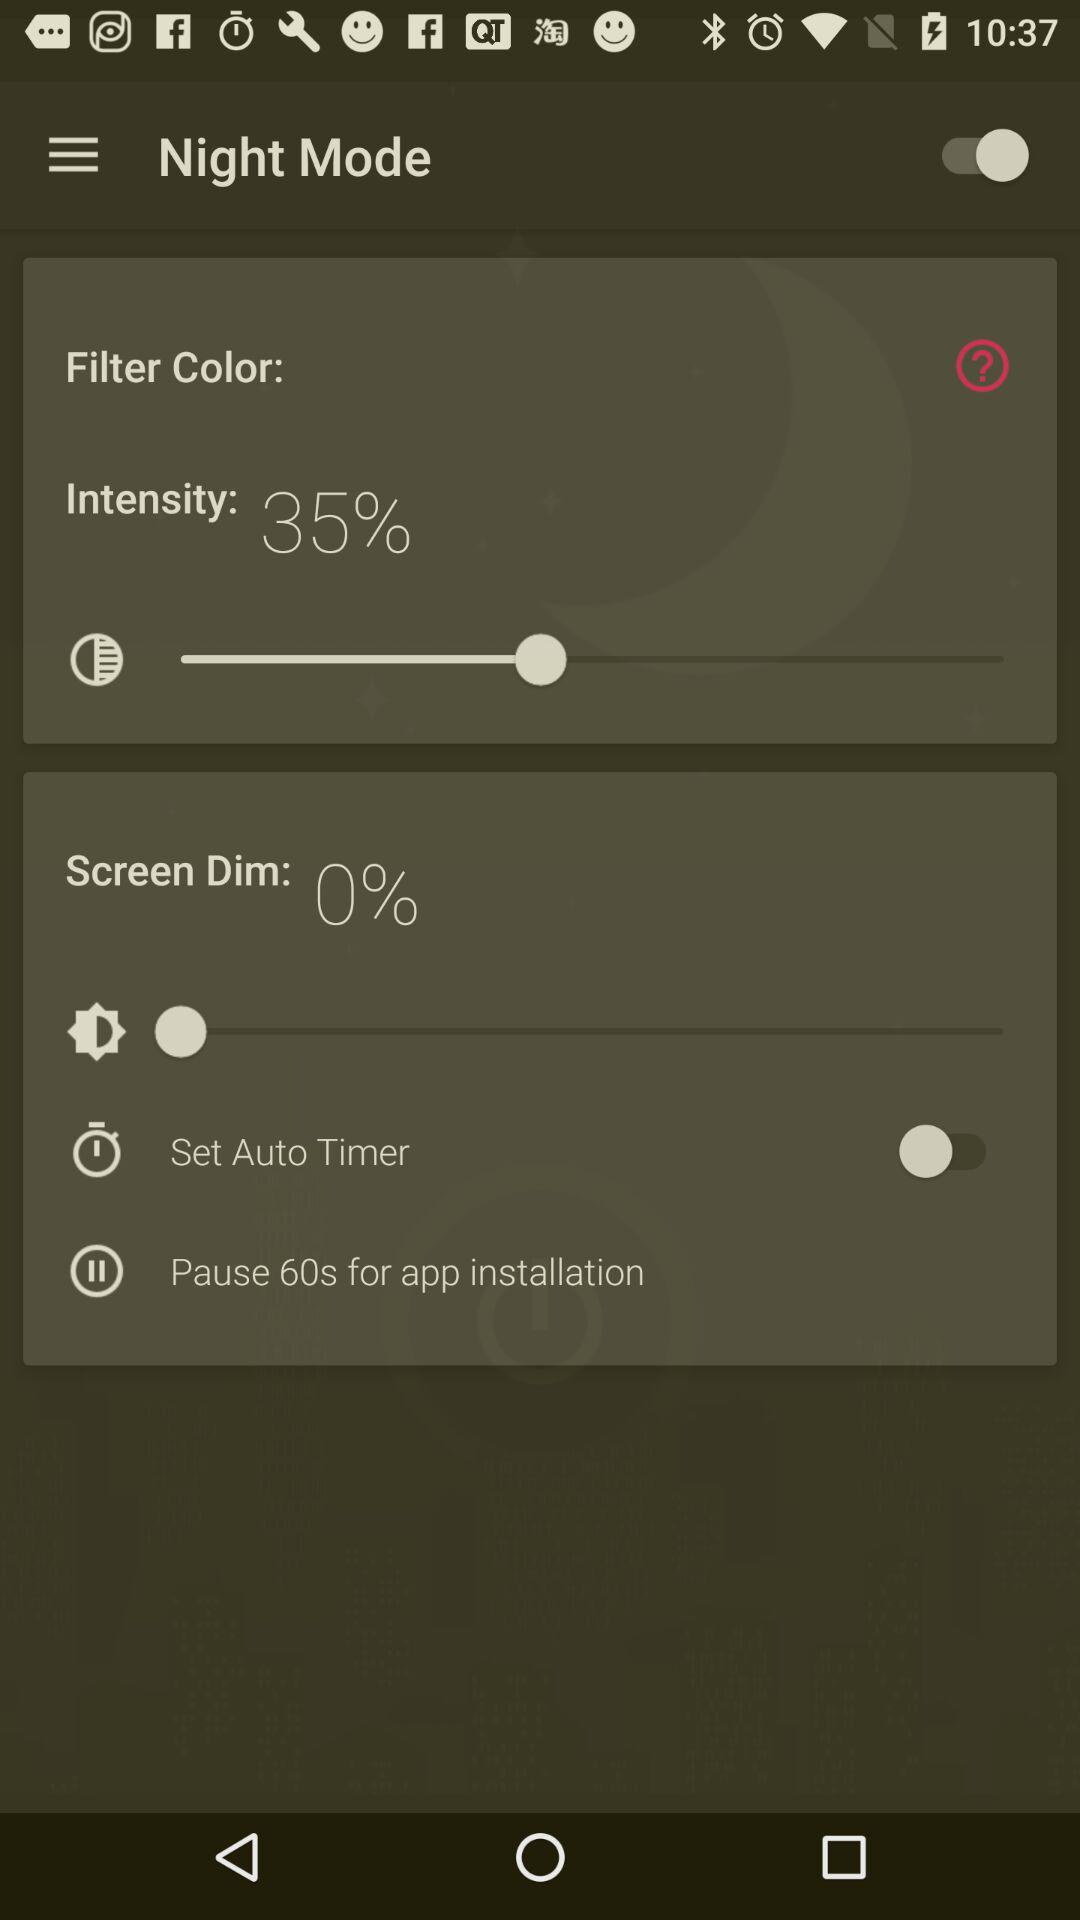What is the selected percentage of "Intensity"? The selected percentage is 35%. 